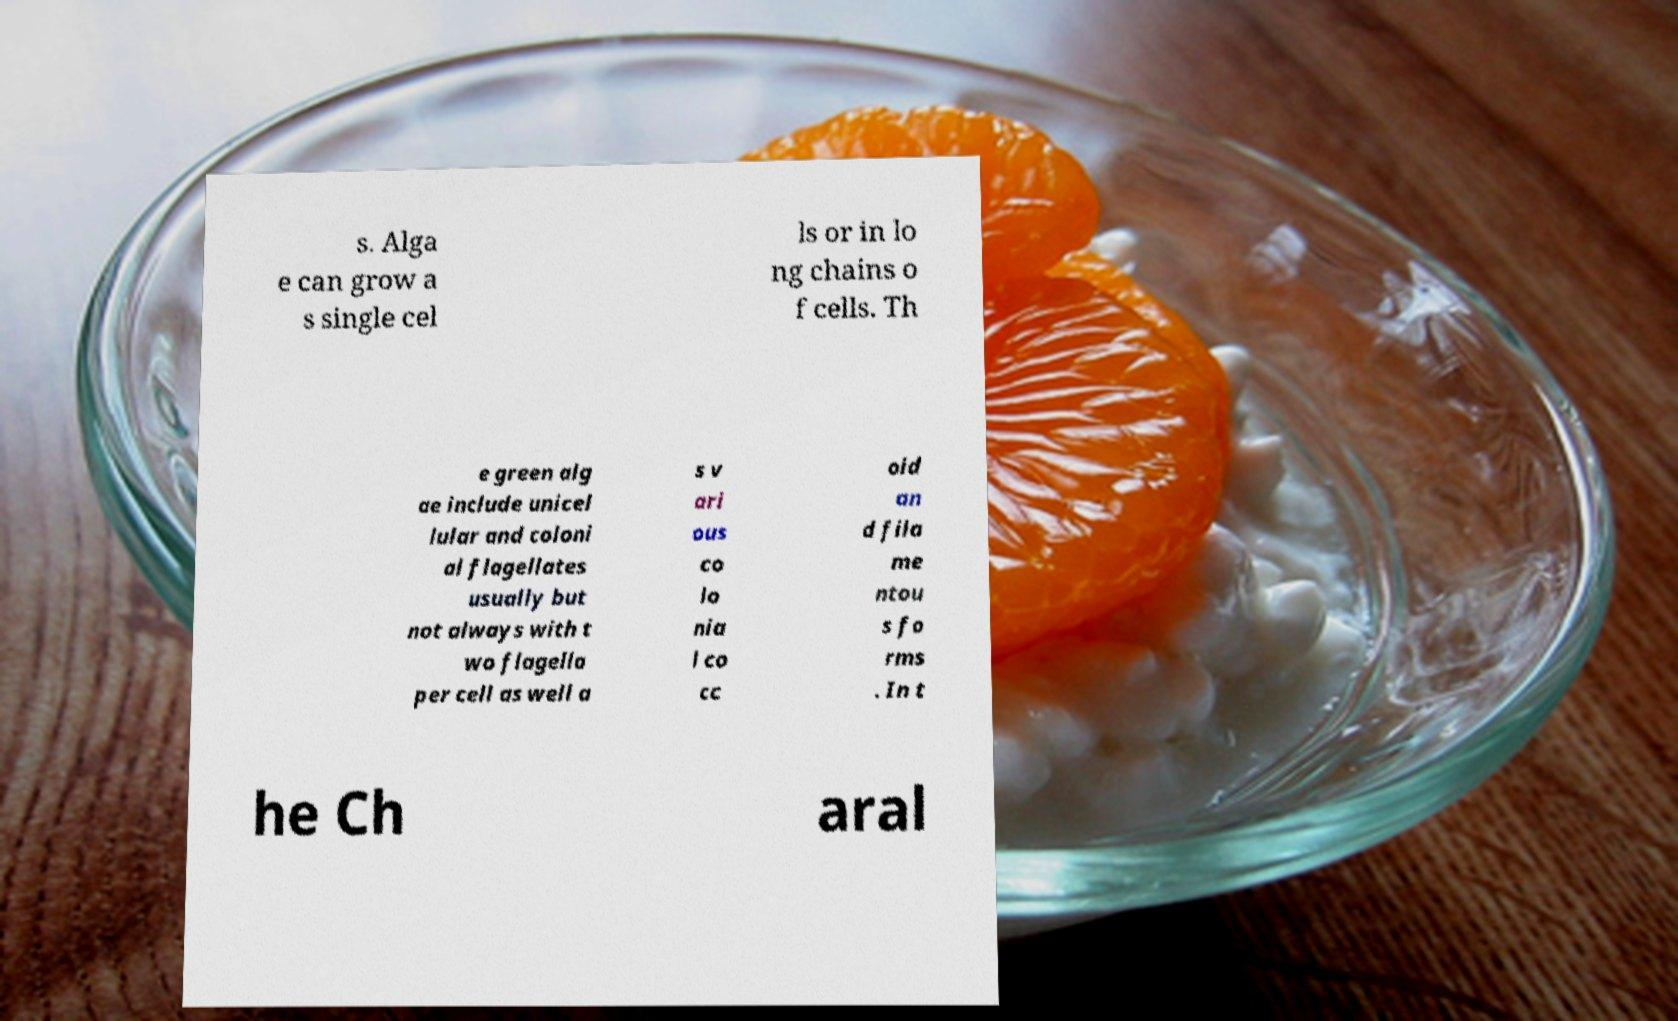Can you read and provide the text displayed in the image?This photo seems to have some interesting text. Can you extract and type it out for me? s. Alga e can grow a s single cel ls or in lo ng chains o f cells. Th e green alg ae include unicel lular and coloni al flagellates usually but not always with t wo flagella per cell as well a s v ari ous co lo nia l co cc oid an d fila me ntou s fo rms . In t he Ch aral 